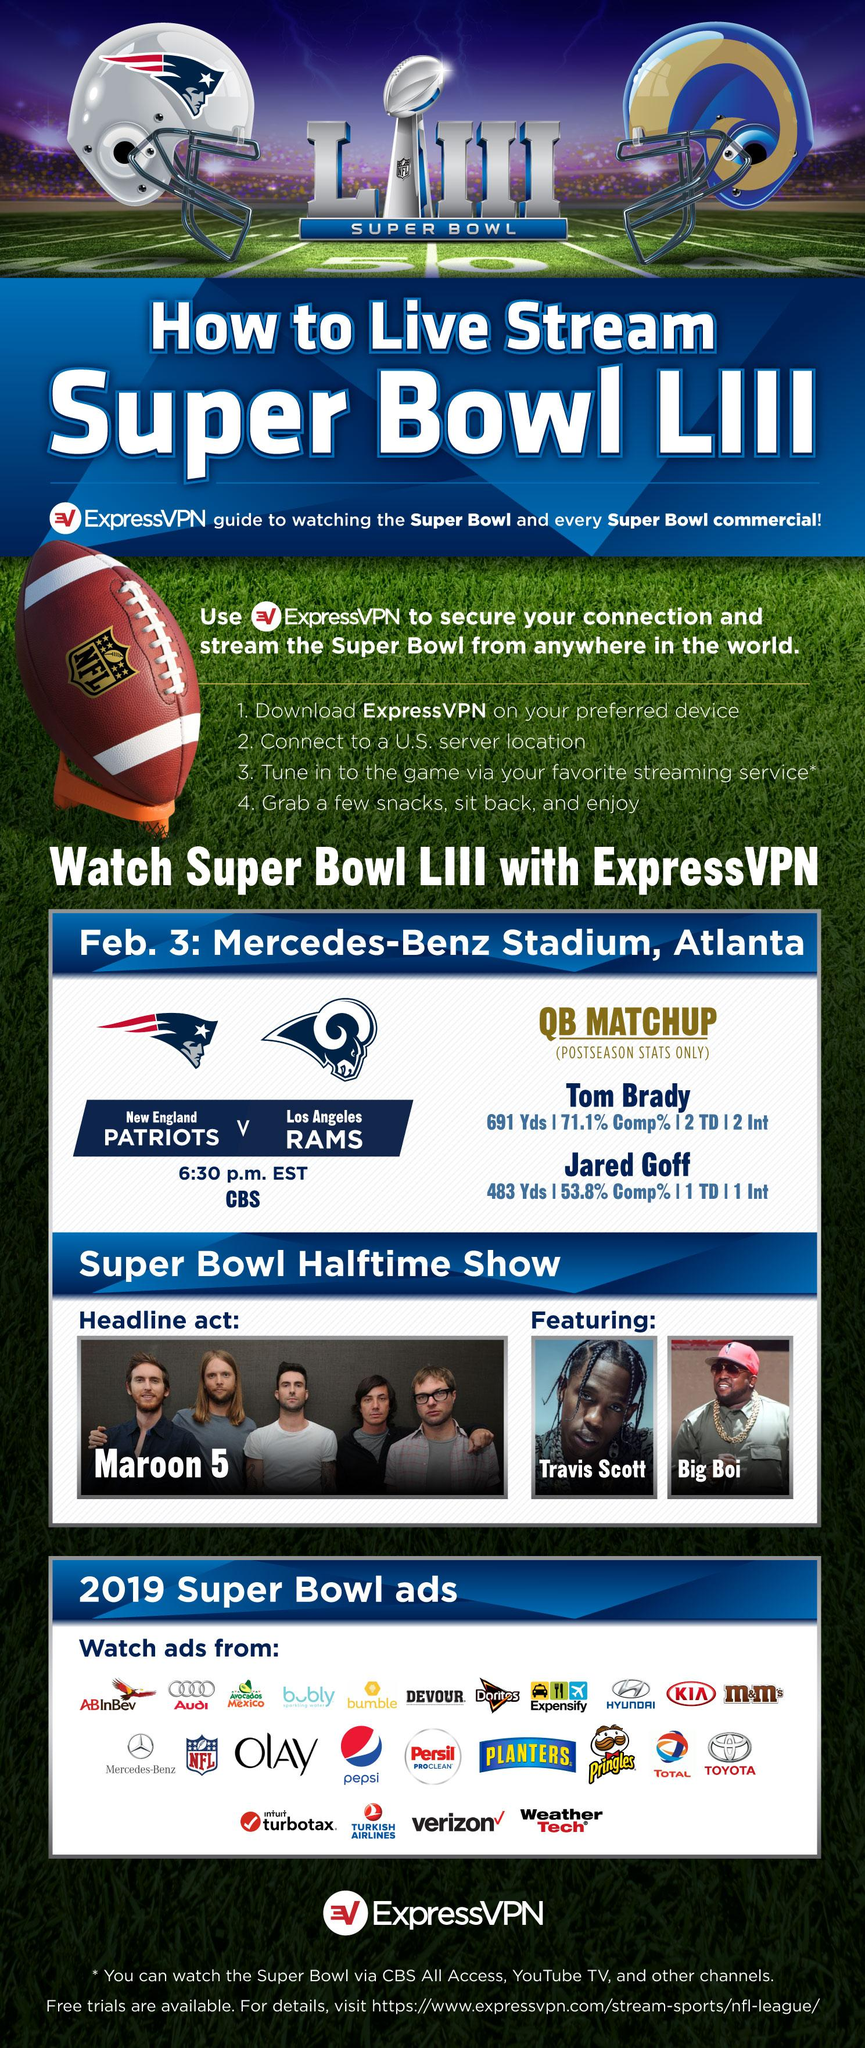Give some essential details in this illustration. The ads feature a total of five car companies. 